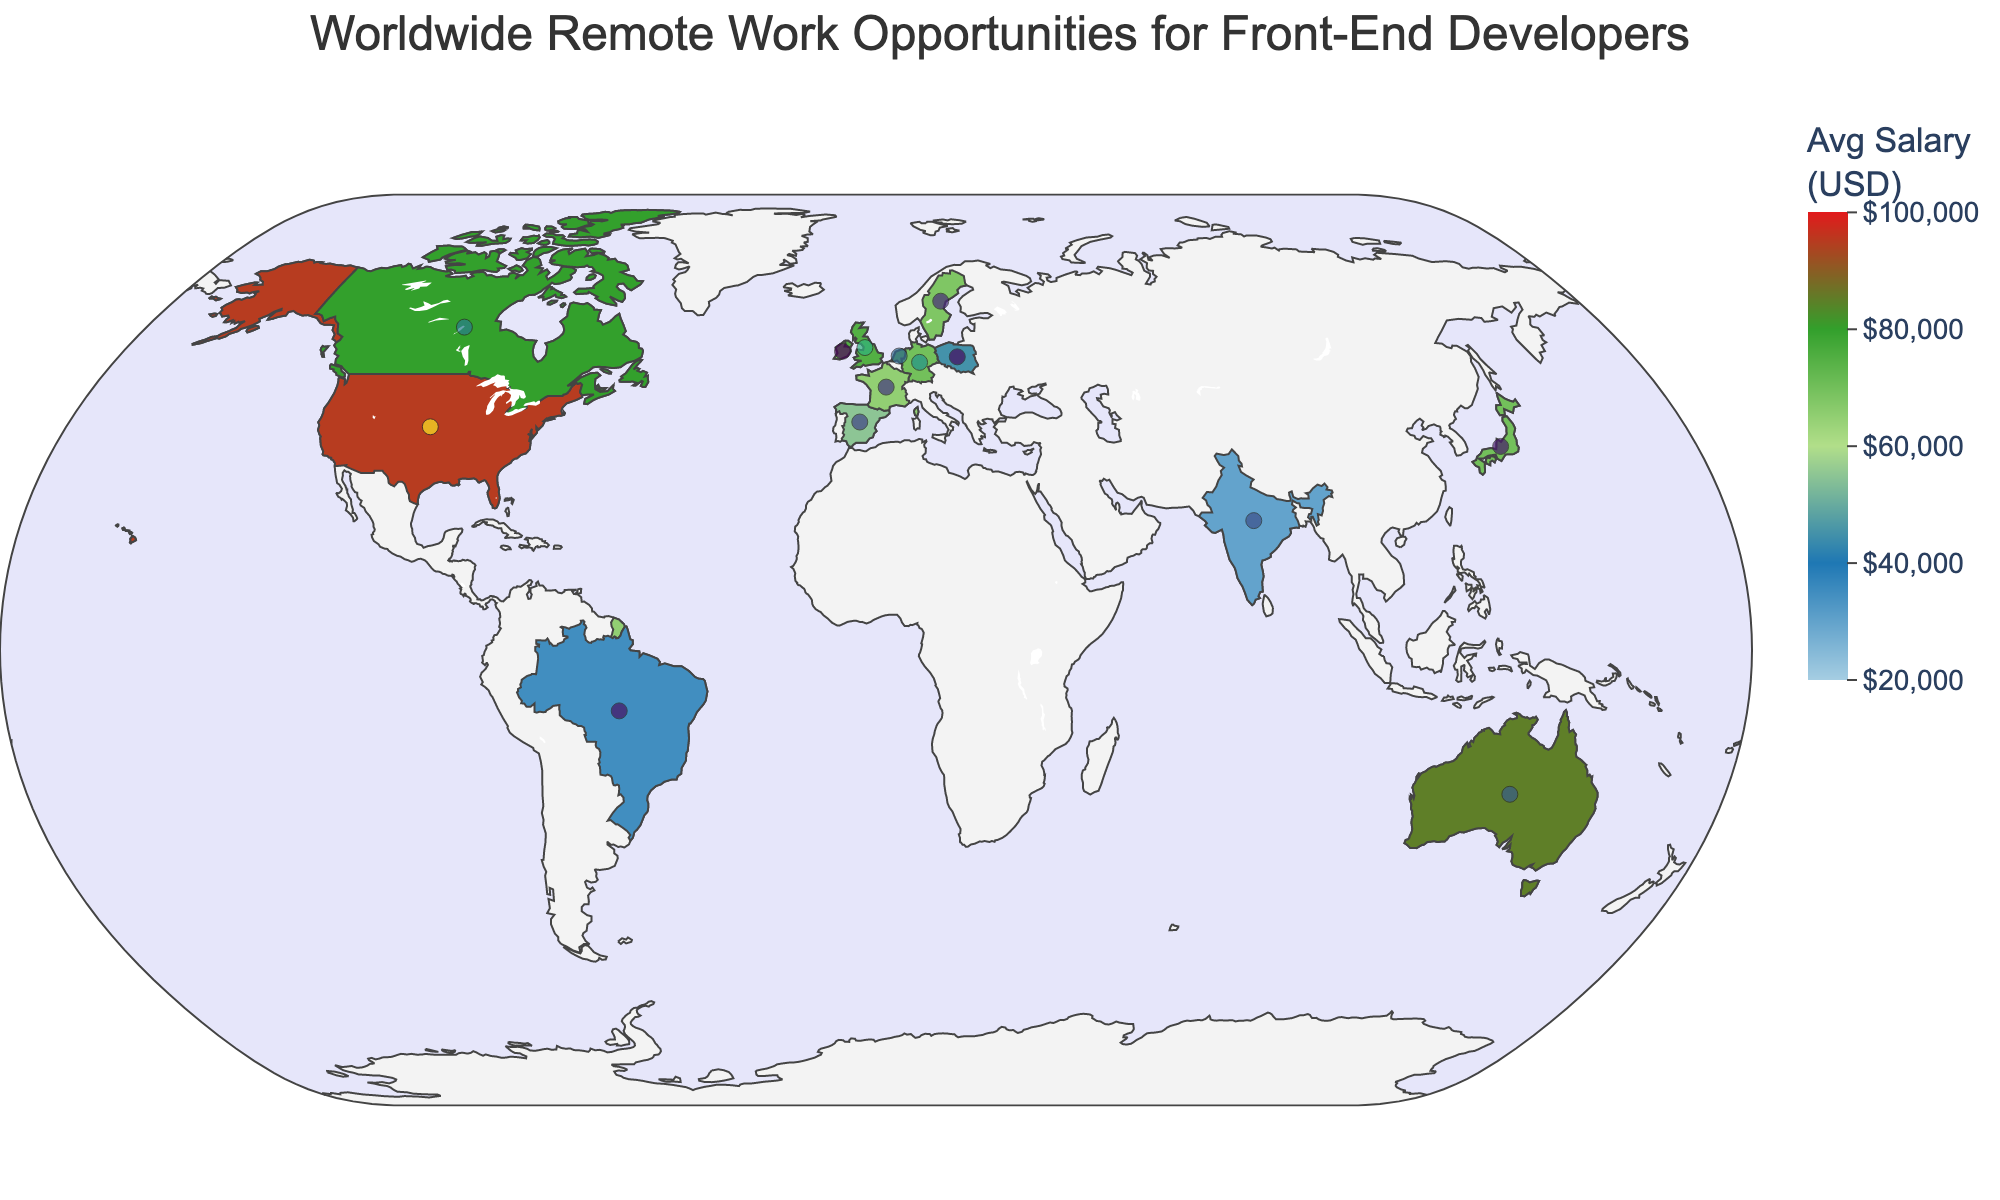How many countries are represented on the map? There are distinct data points representing individual countries on the map. Counting these data points gives us the number of countries.
Answer: 15 Which country has the highest average salary for front-end developers? By examining the color intensity on the map and possibly the labels, the United States has the darkest color, indicating the highest salary.
Answer: United States What is the average salary for front-end developers in Germany? Hovering over Germany on the map reveals that the average salary is $70,000.
Answer: $70,000 Compare the number of remote jobs between the United States and Canada. Which one has more, and by how much? The United States has 1200 remote jobs, and Canada has 550. Subtracting these gives the difference: 1200 - 550 = 650.
Answer: United States, 650 more Which country has the highest demand for the Dojo Toolkit? By looking at the hover data for each country where Dojo Demand is marked "High," the United States, Netherlands, Spain, and Poland have a high demand. We compare these by cross-referencing with their clarity.
Answer: United States, Netherlands, Spain, Poland What is the proportional difference in average salaries between Australia and India? Australia's average salary is $85,000, and India's is $30,000. The proportional difference is calculated as (($85,000 - $30,000) / $30,000) * 100 ≈ 183.33%.
Answer: 183.33% List all countries where the demand for the Dojo Toolkit is labeled as "Low." From the hover data, we can identify countries labeled "Low": Canada, Australia, France, Japan, Singapore.
Answer: Canada, Australia, France, Japan, Singapore What is the difference in the average salary between Sweden and Ireland? Sweden's average salary is $68,000, and Ireland's is $70,000. Subtracting these gives the difference: 70,000 - 68,000 = 2,000.
Answer: $2,000 What information is displayed when hovering over a country? Hovering over a country provides the average salary, number of remote jobs, and Dojo Demand.
Answer: Average Salary, Remote Jobs, Dojo Demand 